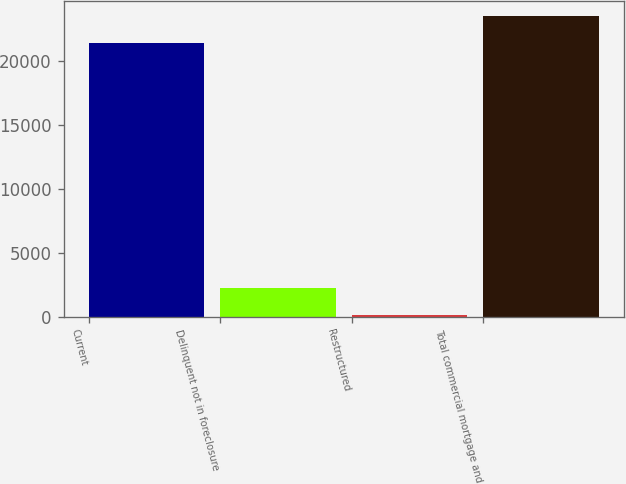Convert chart to OTSL. <chart><loc_0><loc_0><loc_500><loc_500><bar_chart><fcel>Current<fcel>Delinquent not in foreclosure<fcel>Restructured<fcel>Total commercial mortgage and<nl><fcel>21385<fcel>2278<fcel>121<fcel>23542<nl></chart> 